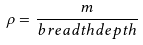Convert formula to latex. <formula><loc_0><loc_0><loc_500><loc_500>\rho = \frac { m } { b r e a d t h d e p t h }</formula> 